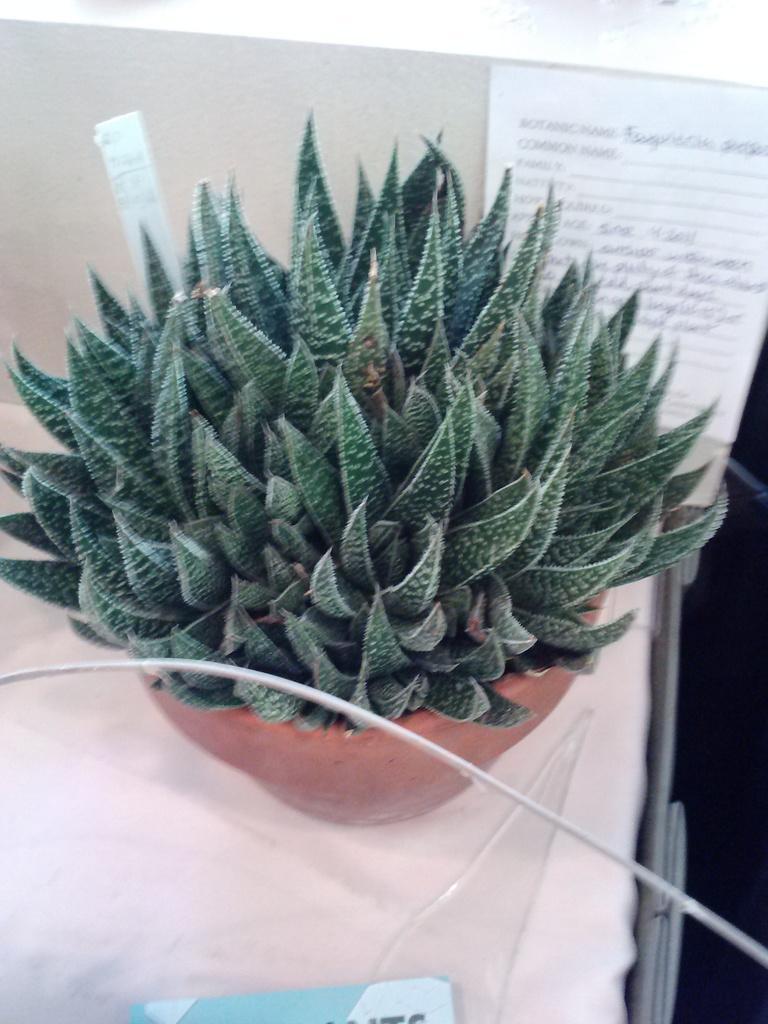Describe this image in one or two sentences. In this picture, we see plant pot is placed on the table which is covered with the white cloth. At the bottom, we see a blue color object. In the background, we see a white table on which a paper containing text is pasted. 